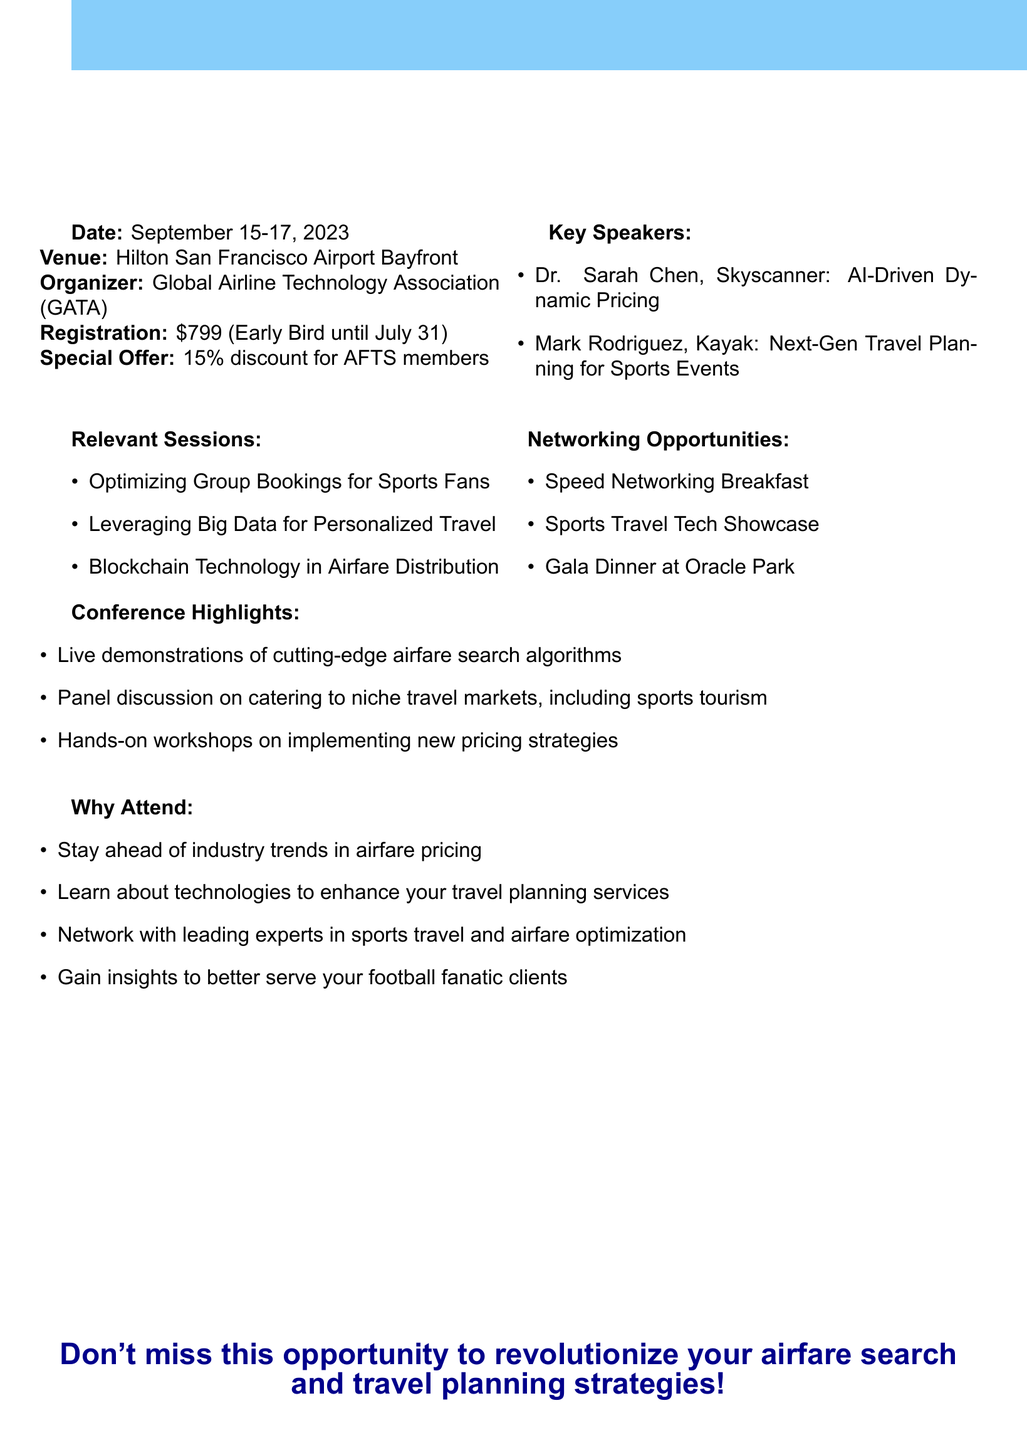What is the event name? The event name is the title of the conference mentioned in the document.
Answer: AirTech Innovations 2023: Revolutionizing Airfare Pricing and Travel Planning When is the conference scheduled? The date provided in the document specifies when the conference will take place.
Answer: September 15-17, 2023 Who is the organizer of the event? The organizer is mentioned explicitly in the document and refers to the managing body of the conference.
Answer: Global Airline Technology Association (GATA) What is the registration fee for the conference? The registration fee is outlined clearly in the document as the cost to attend the event.
Answer: $799 (Early Bird until July 31) Which networking opportunity includes a sports venue? The document lists specific networking opportunities, one of which involves a sports venue.
Answer: Gala Dinner at Oracle Park (Home of the San Francisco Giants) What discount is offered for AFTS members? The special offer for members is stated in the document, specifying the percentage discount available.
Answer: 15% discount What is a key topic discussed by Dr. Sarah Chen? The topic presented by Dr. Sarah Chen is listed among the key speakers’ presentations.
Answer: AI-Driven Dynamic Pricing in the Airline Industry What type of sessions are included for attendees? The document mentions several relevant sessions that provide valuable information for participants.
Answer: Optimizing Group Bookings for Sports Fans Why should attendees consider participating in the conference? The document outlines several benefits for attending which highlight the importance of the event.
Answer: Stay ahead of industry trends in airfare pricing 